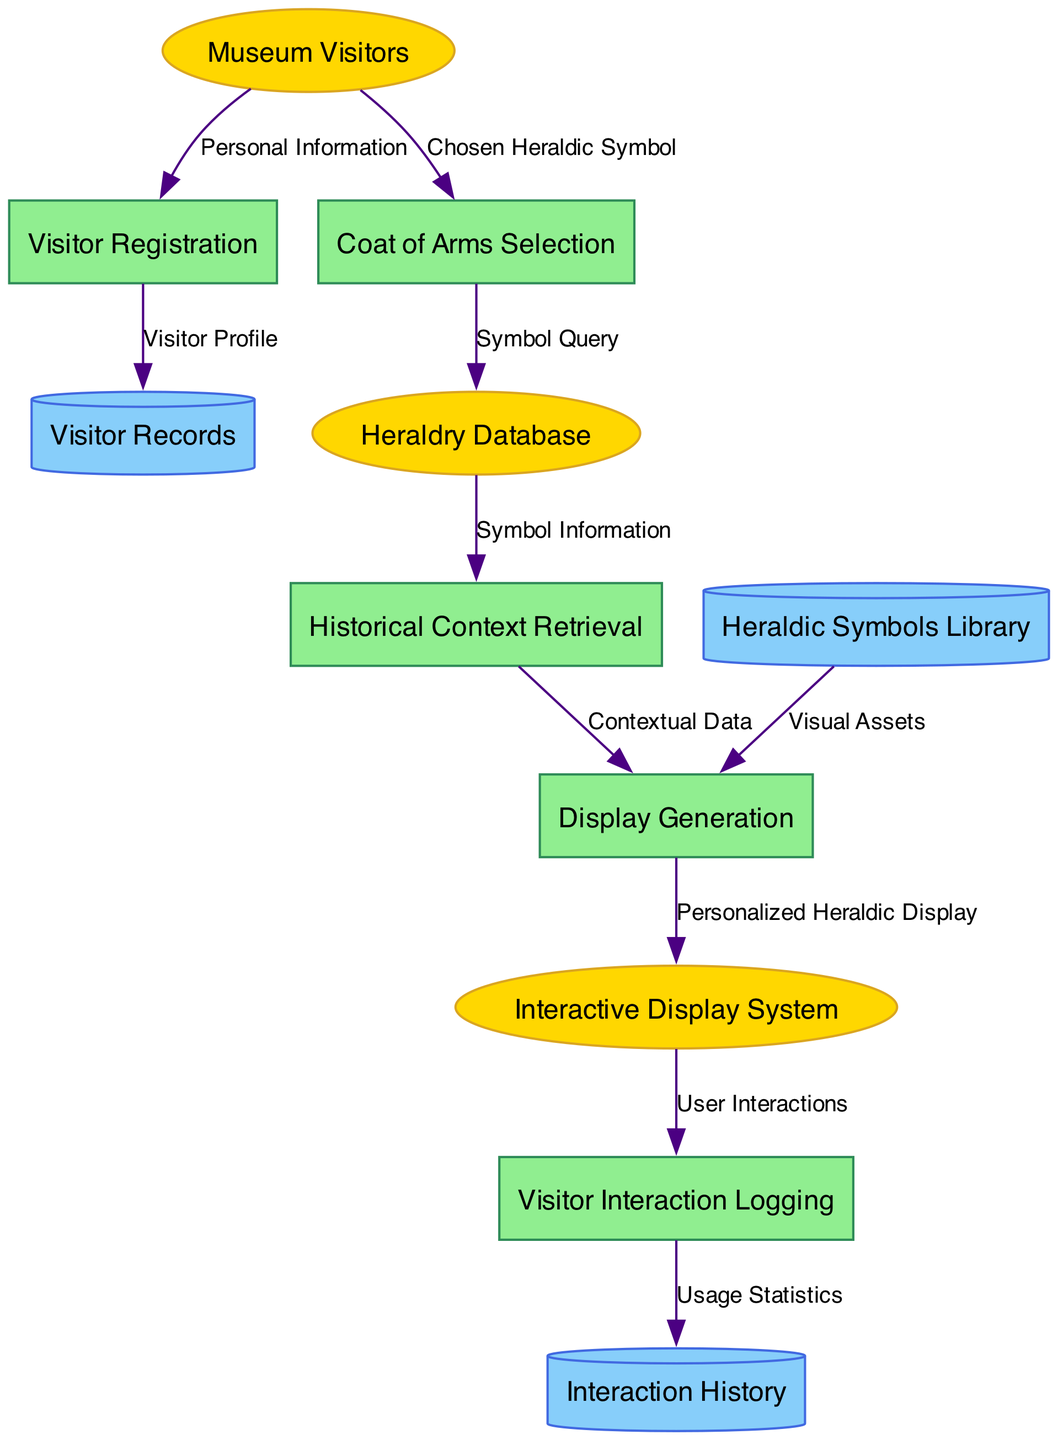What is the first external entity in the diagram? The first external entity listed in the data is "Museum Visitors". The diagram indicates external entities at the beginning, and by reviewing that section, we identify the first one.
Answer: Museum Visitors How many processes are there in the diagram? By counting the number of items listed under the "processes" section, we find there are five processes: Visitor Registration, Coat of Arms Selection, Historical Context Retrieval, Display Generation, and Visitor Interaction Logging.
Answer: 5 What type of node is "Interaction History"? "Interaction History" is classified as a data store in the diagram. Data stores are typically represented by cylindrical shapes, as shown in the provided data.
Answer: Data Store What data flow connects "Museum Visitors" to "Visitor Registration"? The flow from "Museum Visitors" to "Visitor Registration" carries the data labeled "Personal Information". This is explicitly stated in the data flows section.
Answer: Personal Information Which process retrieves information from the "Heraldry Database"? The process "Historical Context Retrieval" receives data from the "Heraldry Database" as indicated in the data flows section. By following the respective connections in the diagram, we can trace this flow.
Answer: Historical Context Retrieval What is the last process in the data flow sequence? The last process in the sequence is "Visitor Interaction Logging," which is the final step before data is recorded in the "Interaction History" data store. We check the order of the processes listed to determine this.
Answer: Visitor Interaction Logging Which data store is used for storing visitor profiles? The "Visitor Records" data store is where visitor profiles are stored, as shown by the flow from "Visitor Registration" to "Visitor Records". This is indicated directly in the data flows.
Answer: Visitor Records What does "Display Generation" send to the "Interactive Display System"? "Display Generation" sends "Personalized Heraldic Display" to the "Interactive Display System". This flow is explicitly stated in the data flows section of the diagram.
Answer: Personalized Heraldic Display How does "Coat of Arms Selection" affect the "Heraldry Database"? "Coat of Arms Selection" affects the "Heraldry Database" by sending a "Symbol Query" to it, which is represented in the data flow connecting these two processes. This shows the interaction between the selected coat of arms and the database.
Answer: Symbol Query 